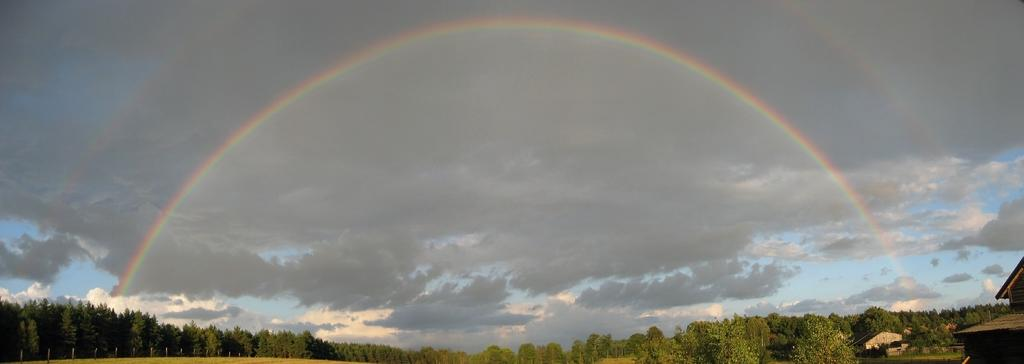What type of vegetation can be seen in the image? There are trees and grass in the image. What type of structures are visible in the image? There are houses in the image. What is visible on the ground in the image? The ground is visible in the image with some objects. What can be seen in the sky in the image? A rainbow is present in the image, and clouds are visible in the sky. How many apples are hanging from the trees in the image? There are no apples present in the image; only trees and grass are visible. What color is the eye of the person in the image? There is no person present in the image, so it is not possible to determine the color of their eye. 